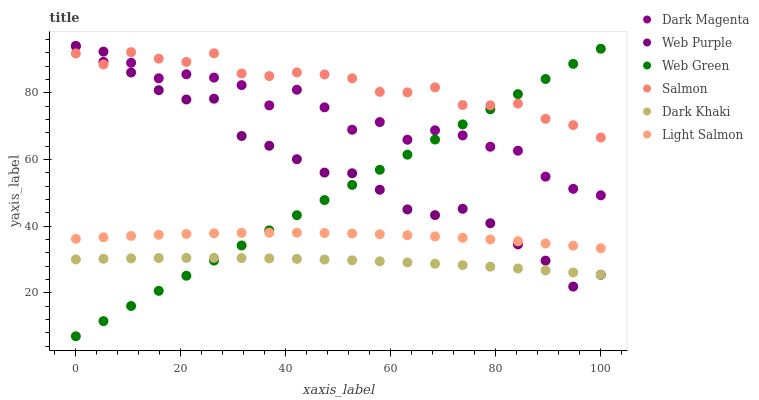Does Dark Khaki have the minimum area under the curve?
Answer yes or no. Yes. Does Salmon have the maximum area under the curve?
Answer yes or no. Yes. Does Dark Magenta have the minimum area under the curve?
Answer yes or no. No. Does Dark Magenta have the maximum area under the curve?
Answer yes or no. No. Is Web Green the smoothest?
Answer yes or no. Yes. Is Dark Magenta the roughest?
Answer yes or no. Yes. Is Salmon the smoothest?
Answer yes or no. No. Is Salmon the roughest?
Answer yes or no. No. Does Web Green have the lowest value?
Answer yes or no. Yes. Does Dark Magenta have the lowest value?
Answer yes or no. No. Does Web Purple have the highest value?
Answer yes or no. Yes. Does Salmon have the highest value?
Answer yes or no. No. Is Dark Khaki less than Dark Magenta?
Answer yes or no. Yes. Is Dark Magenta greater than Light Salmon?
Answer yes or no. Yes. Does Salmon intersect Web Purple?
Answer yes or no. Yes. Is Salmon less than Web Purple?
Answer yes or no. No. Is Salmon greater than Web Purple?
Answer yes or no. No. Does Dark Khaki intersect Dark Magenta?
Answer yes or no. No. 